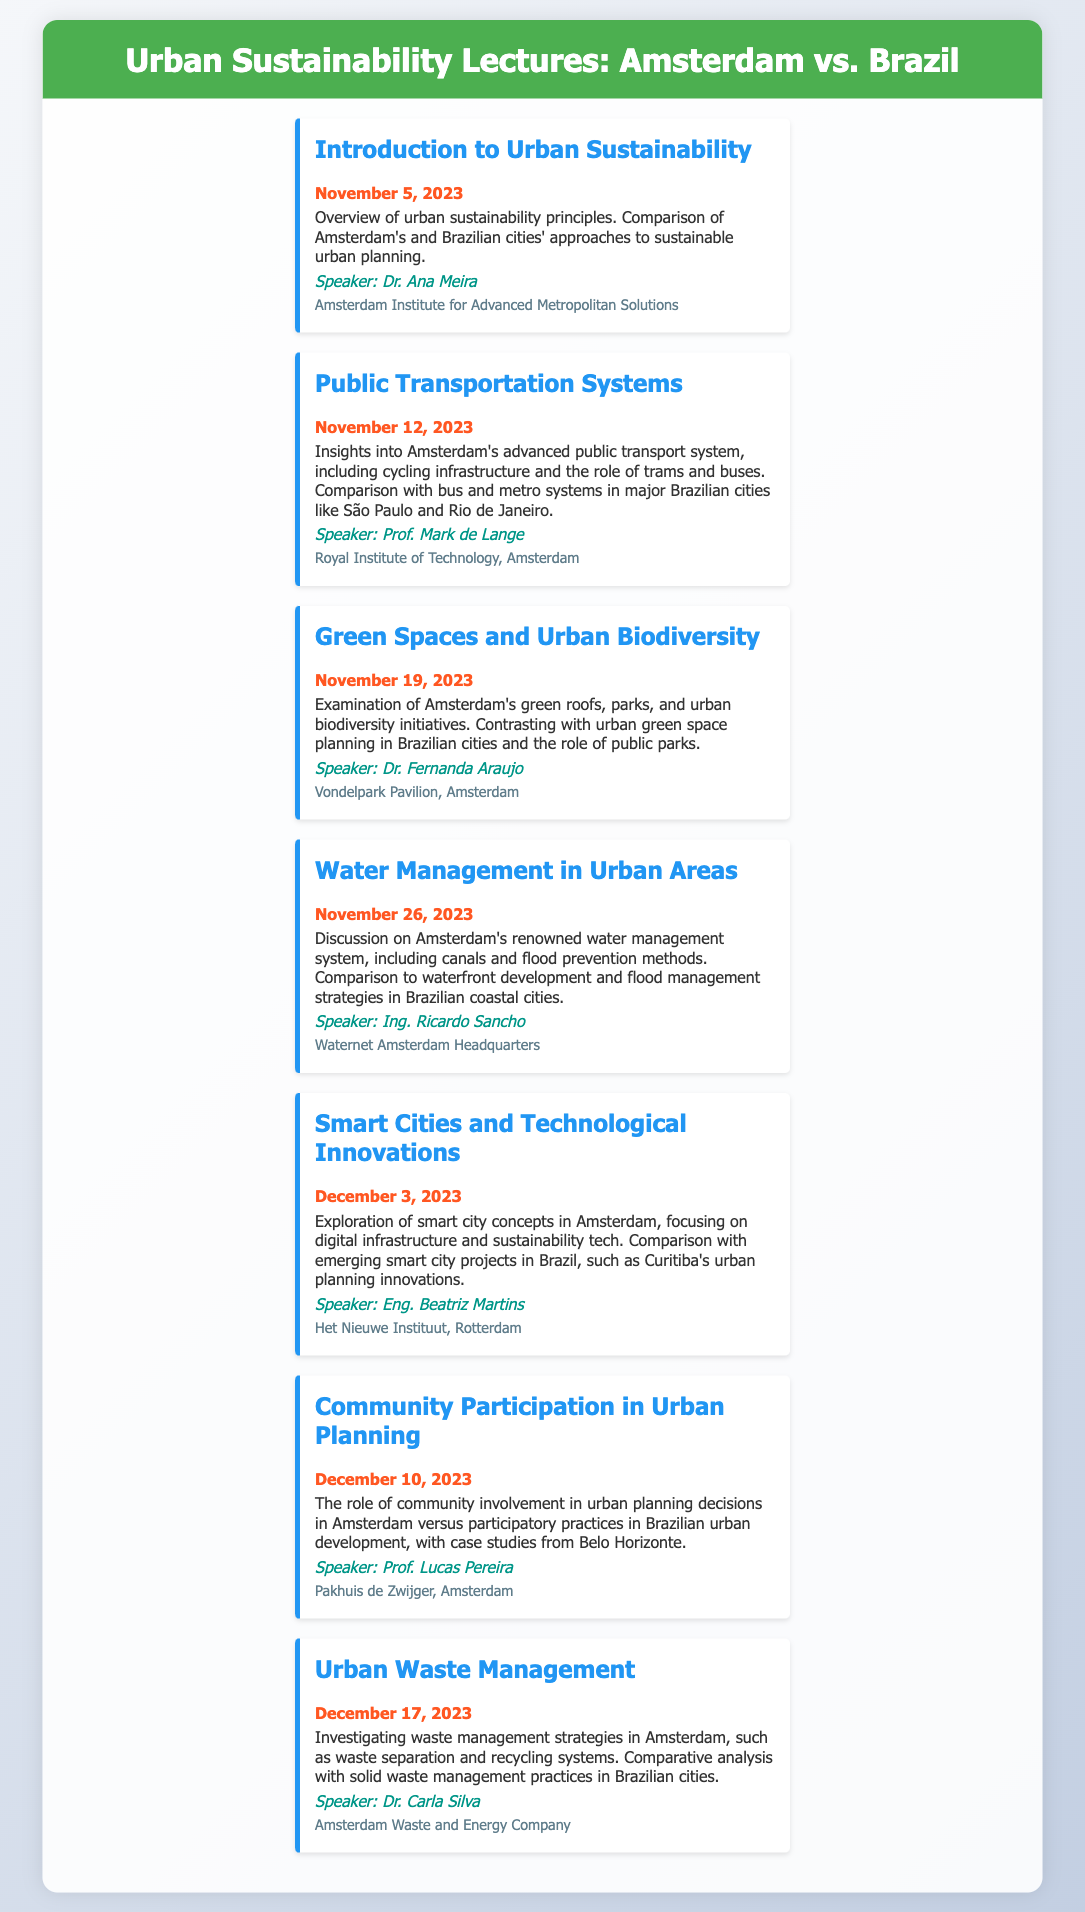What is the date of the Introduction to Urban Sustainability lecture? The date is explicitly mentioned in the event, which is November 5, 2023.
Answer: November 5, 2023 Who is the speaker for the Public Transportation Systems lecture? The speaker's name is provided in the event details for this lecture, which is Prof. Mark de Lange.
Answer: Prof. Mark de Lange What location will host the Green Spaces and Urban Biodiversity lecture? The document specifies the location for this event, which is Vondelpark Pavilion, Amsterdam.
Answer: Vondelpark Pavilion, Amsterdam How many lectures are scheduled before December? The document lists the events, with three scheduled in November (5th, 12th, and 19th).
Answer: 3 What main topic is discussed on December 10, 2023? The main topic is about community involvement in urban planning decisions.
Answer: Community Participation in Urban Planning What feature makes Amsterdam's water management system notable? The document highlights Amsterdam’s renowned water management system, including canals and flood prevention methods.
Answer: Canals and flood prevention methods Compare the public transport systems of Amsterdam and Brazil based on the relevant lecture. The lecture provides insights into Amsterdam's advanced public transport system and compares it with bus and metro systems in Brazilian cities.
Answer: Advanced public transport vs. bus and metro systems Which lecture focuses on technological innovations in urban settings? The Smart Cities and Technological Innovations lecture specifically covers this theme.
Answer: Smart Cities and Technological Innovations 